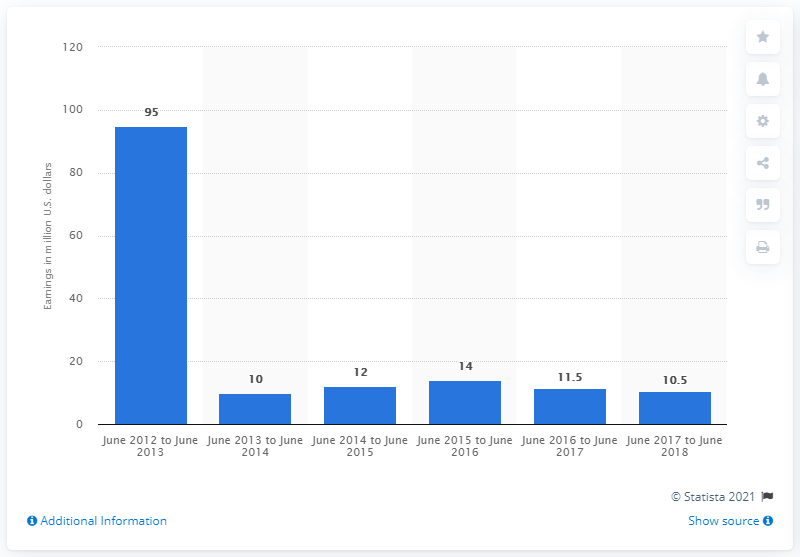List a handful of essential elements in this visual. Erika Leonard earned approximately $10.5 million between June 2017 and June 2018. 